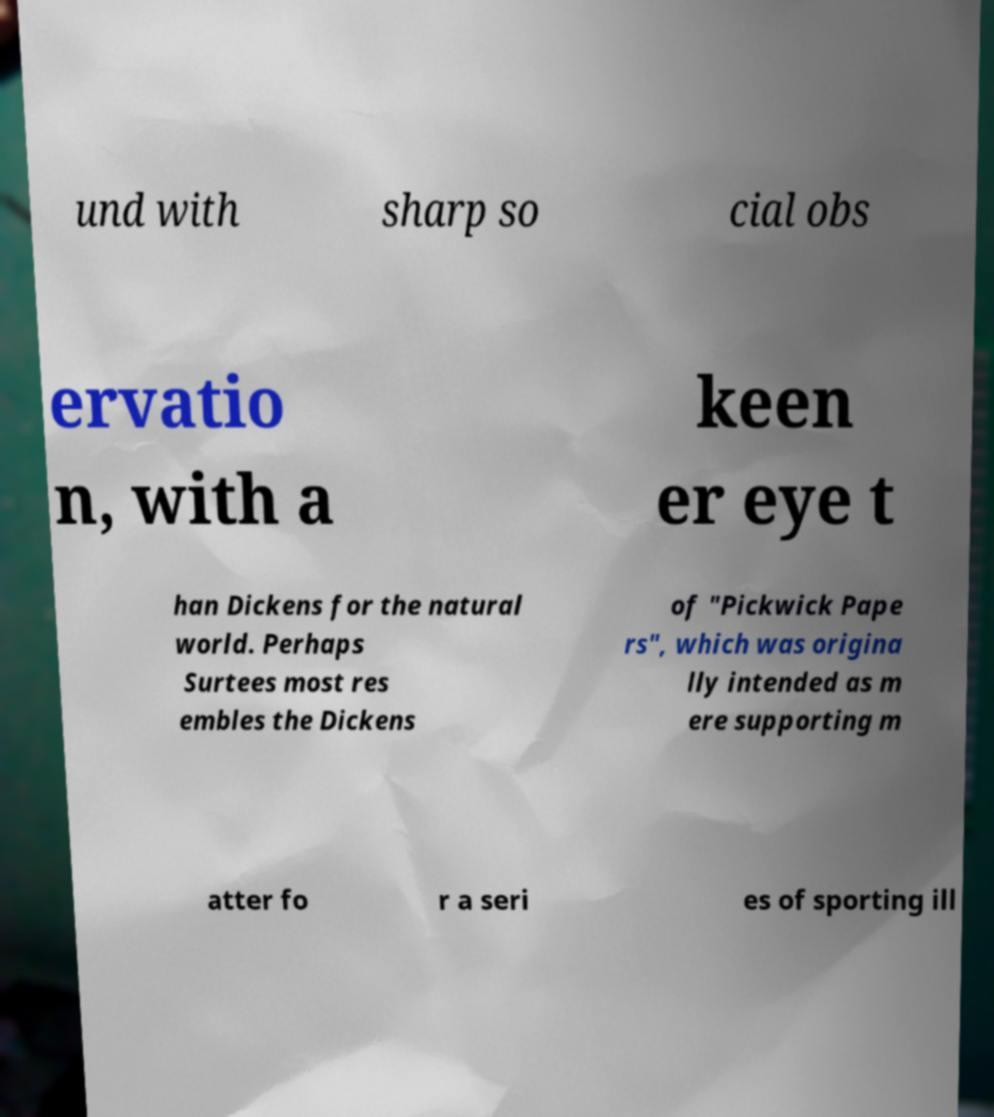Could you extract and type out the text from this image? und with sharp so cial obs ervatio n, with a keen er eye t han Dickens for the natural world. Perhaps Surtees most res embles the Dickens of "Pickwick Pape rs", which was origina lly intended as m ere supporting m atter fo r a seri es of sporting ill 